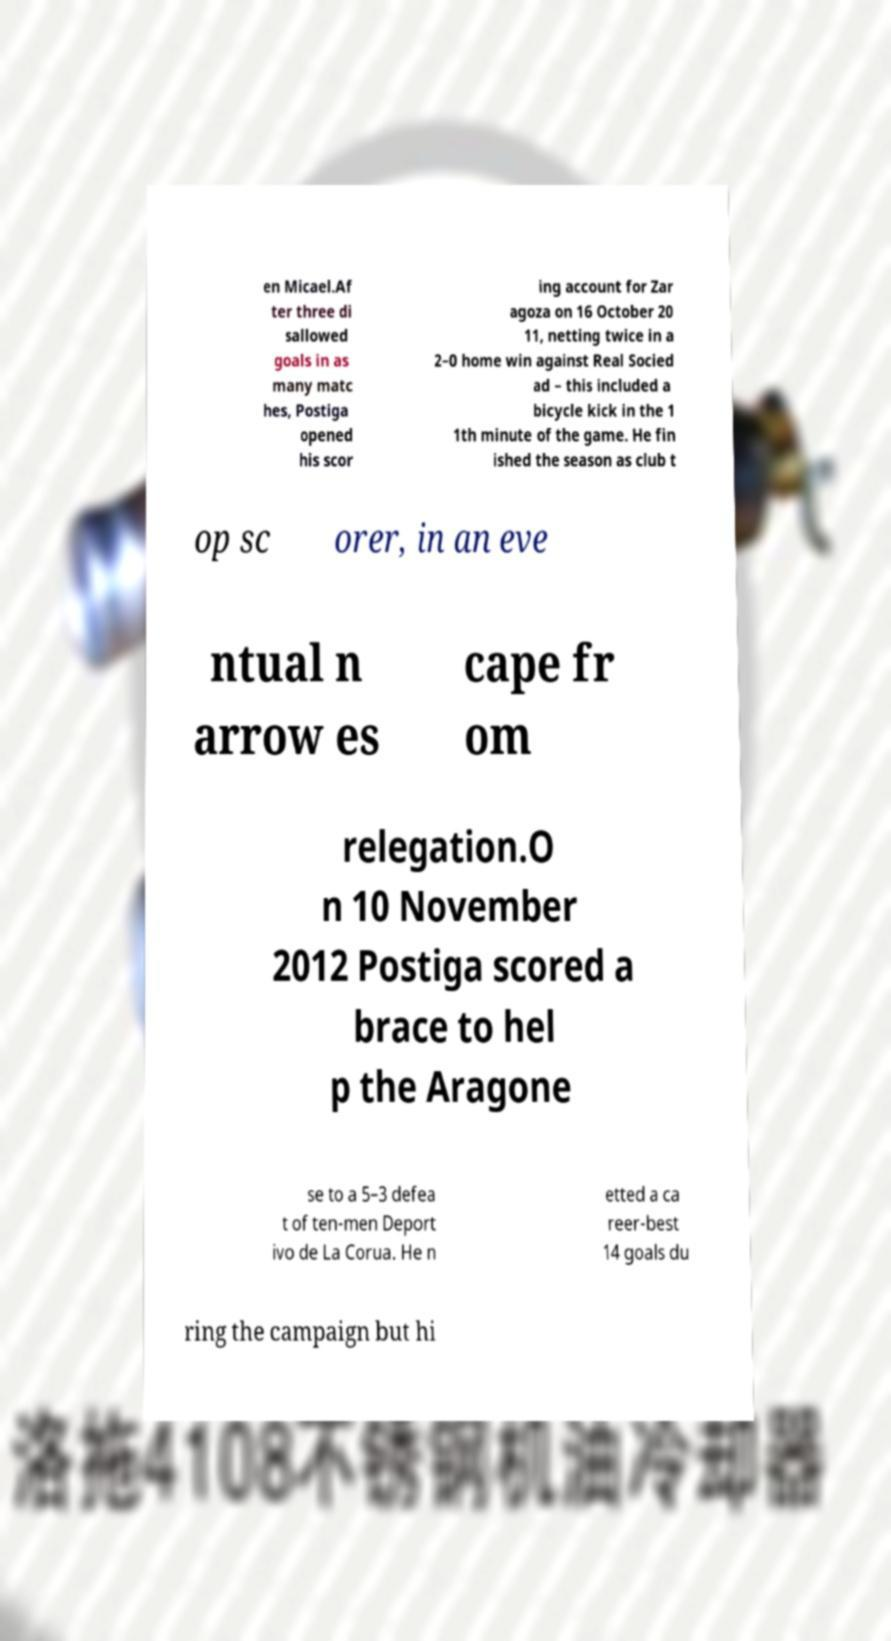There's text embedded in this image that I need extracted. Can you transcribe it verbatim? en Micael.Af ter three di sallowed goals in as many matc hes, Postiga opened his scor ing account for Zar agoza on 16 October 20 11, netting twice in a 2–0 home win against Real Socied ad – this included a bicycle kick in the 1 1th minute of the game. He fin ished the season as club t op sc orer, in an eve ntual n arrow es cape fr om relegation.O n 10 November 2012 Postiga scored a brace to hel p the Aragone se to a 5–3 defea t of ten-men Deport ivo de La Corua. He n etted a ca reer-best 14 goals du ring the campaign but hi 